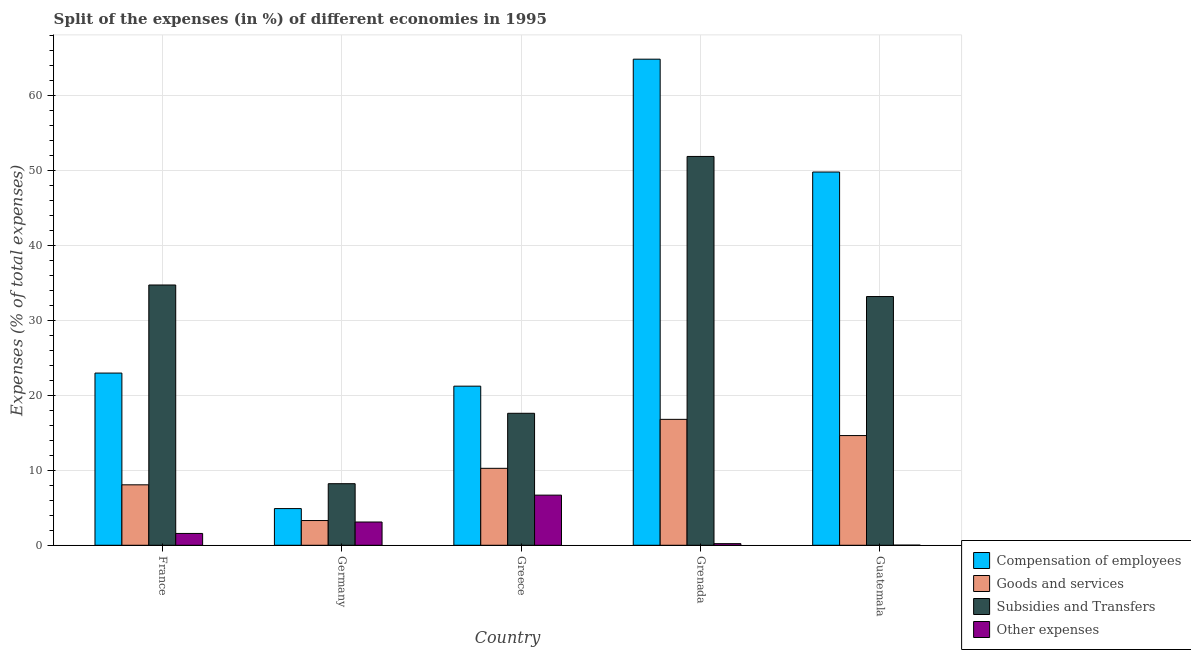How many different coloured bars are there?
Give a very brief answer. 4. How many groups of bars are there?
Your answer should be very brief. 5. Are the number of bars per tick equal to the number of legend labels?
Give a very brief answer. Yes. How many bars are there on the 2nd tick from the right?
Provide a short and direct response. 4. What is the label of the 3rd group of bars from the left?
Offer a very short reply. Greece. What is the percentage of amount spent on other expenses in Grenada?
Offer a terse response. 0.22. Across all countries, what is the maximum percentage of amount spent on other expenses?
Your answer should be compact. 6.69. Across all countries, what is the minimum percentage of amount spent on subsidies?
Your response must be concise. 8.22. In which country was the percentage of amount spent on other expenses maximum?
Make the answer very short. Greece. In which country was the percentage of amount spent on goods and services minimum?
Make the answer very short. Germany. What is the total percentage of amount spent on other expenses in the graph?
Offer a very short reply. 11.61. What is the difference between the percentage of amount spent on other expenses in France and that in Germany?
Ensure brevity in your answer.  -1.52. What is the difference between the percentage of amount spent on goods and services in Grenada and the percentage of amount spent on other expenses in Greece?
Offer a very short reply. 10.11. What is the average percentage of amount spent on subsidies per country?
Offer a terse response. 29.12. What is the difference between the percentage of amount spent on subsidies and percentage of amount spent on goods and services in Guatemala?
Keep it short and to the point. 18.55. In how many countries, is the percentage of amount spent on other expenses greater than 58 %?
Your response must be concise. 0. What is the ratio of the percentage of amount spent on subsidies in Greece to that in Grenada?
Make the answer very short. 0.34. Is the percentage of amount spent on other expenses in France less than that in Greece?
Offer a very short reply. Yes. Is the difference between the percentage of amount spent on goods and services in France and Germany greater than the difference between the percentage of amount spent on other expenses in France and Germany?
Ensure brevity in your answer.  Yes. What is the difference between the highest and the second highest percentage of amount spent on subsidies?
Your answer should be compact. 17.15. What is the difference between the highest and the lowest percentage of amount spent on other expenses?
Your response must be concise. 6.67. Is it the case that in every country, the sum of the percentage of amount spent on compensation of employees and percentage of amount spent on other expenses is greater than the sum of percentage of amount spent on goods and services and percentage of amount spent on subsidies?
Provide a succinct answer. Yes. What does the 2nd bar from the left in Greece represents?
Offer a terse response. Goods and services. What does the 2nd bar from the right in Germany represents?
Give a very brief answer. Subsidies and Transfers. How many bars are there?
Your answer should be very brief. 20. How many countries are there in the graph?
Your answer should be compact. 5. What is the difference between two consecutive major ticks on the Y-axis?
Offer a very short reply. 10. Are the values on the major ticks of Y-axis written in scientific E-notation?
Make the answer very short. No. Does the graph contain grids?
Provide a succinct answer. Yes. Where does the legend appear in the graph?
Provide a succinct answer. Bottom right. How many legend labels are there?
Your answer should be very brief. 4. What is the title of the graph?
Offer a very short reply. Split of the expenses (in %) of different economies in 1995. What is the label or title of the Y-axis?
Your answer should be very brief. Expenses (% of total expenses). What is the Expenses (% of total expenses) in Compensation of employees in France?
Make the answer very short. 22.97. What is the Expenses (% of total expenses) of Goods and services in France?
Provide a succinct answer. 8.07. What is the Expenses (% of total expenses) in Subsidies and Transfers in France?
Your answer should be compact. 34.73. What is the Expenses (% of total expenses) of Other expenses in France?
Your answer should be very brief. 1.58. What is the Expenses (% of total expenses) of Compensation of employees in Germany?
Make the answer very short. 4.9. What is the Expenses (% of total expenses) of Goods and services in Germany?
Provide a succinct answer. 3.3. What is the Expenses (% of total expenses) in Subsidies and Transfers in Germany?
Your answer should be compact. 8.22. What is the Expenses (% of total expenses) of Other expenses in Germany?
Provide a succinct answer. 3.1. What is the Expenses (% of total expenses) of Compensation of employees in Greece?
Ensure brevity in your answer.  21.23. What is the Expenses (% of total expenses) in Goods and services in Greece?
Your response must be concise. 10.27. What is the Expenses (% of total expenses) of Subsidies and Transfers in Greece?
Provide a succinct answer. 17.61. What is the Expenses (% of total expenses) of Other expenses in Greece?
Keep it short and to the point. 6.69. What is the Expenses (% of total expenses) in Compensation of employees in Grenada?
Give a very brief answer. 64.85. What is the Expenses (% of total expenses) in Goods and services in Grenada?
Keep it short and to the point. 16.8. What is the Expenses (% of total expenses) in Subsidies and Transfers in Grenada?
Offer a very short reply. 51.88. What is the Expenses (% of total expenses) of Other expenses in Grenada?
Offer a very short reply. 0.22. What is the Expenses (% of total expenses) in Compensation of employees in Guatemala?
Your answer should be very brief. 49.8. What is the Expenses (% of total expenses) in Goods and services in Guatemala?
Give a very brief answer. 14.64. What is the Expenses (% of total expenses) of Subsidies and Transfers in Guatemala?
Offer a terse response. 33.19. What is the Expenses (% of total expenses) of Other expenses in Guatemala?
Make the answer very short. 0.02. Across all countries, what is the maximum Expenses (% of total expenses) of Compensation of employees?
Make the answer very short. 64.85. Across all countries, what is the maximum Expenses (% of total expenses) in Goods and services?
Your answer should be compact. 16.8. Across all countries, what is the maximum Expenses (% of total expenses) in Subsidies and Transfers?
Make the answer very short. 51.88. Across all countries, what is the maximum Expenses (% of total expenses) in Other expenses?
Keep it short and to the point. 6.69. Across all countries, what is the minimum Expenses (% of total expenses) of Compensation of employees?
Keep it short and to the point. 4.9. Across all countries, what is the minimum Expenses (% of total expenses) of Goods and services?
Provide a short and direct response. 3.3. Across all countries, what is the minimum Expenses (% of total expenses) in Subsidies and Transfers?
Offer a terse response. 8.22. Across all countries, what is the minimum Expenses (% of total expenses) of Other expenses?
Provide a short and direct response. 0.02. What is the total Expenses (% of total expenses) of Compensation of employees in the graph?
Make the answer very short. 163.75. What is the total Expenses (% of total expenses) in Goods and services in the graph?
Make the answer very short. 53.07. What is the total Expenses (% of total expenses) of Subsidies and Transfers in the graph?
Your answer should be compact. 145.61. What is the total Expenses (% of total expenses) of Other expenses in the graph?
Offer a very short reply. 11.61. What is the difference between the Expenses (% of total expenses) of Compensation of employees in France and that in Germany?
Your answer should be very brief. 18.08. What is the difference between the Expenses (% of total expenses) in Goods and services in France and that in Germany?
Your response must be concise. 4.77. What is the difference between the Expenses (% of total expenses) in Subsidies and Transfers in France and that in Germany?
Provide a succinct answer. 26.51. What is the difference between the Expenses (% of total expenses) in Other expenses in France and that in Germany?
Ensure brevity in your answer.  -1.52. What is the difference between the Expenses (% of total expenses) in Compensation of employees in France and that in Greece?
Your answer should be compact. 1.75. What is the difference between the Expenses (% of total expenses) of Goods and services in France and that in Greece?
Your answer should be compact. -2.2. What is the difference between the Expenses (% of total expenses) in Subsidies and Transfers in France and that in Greece?
Offer a very short reply. 17.12. What is the difference between the Expenses (% of total expenses) of Other expenses in France and that in Greece?
Offer a terse response. -5.11. What is the difference between the Expenses (% of total expenses) in Compensation of employees in France and that in Grenada?
Give a very brief answer. -41.88. What is the difference between the Expenses (% of total expenses) of Goods and services in France and that in Grenada?
Provide a succinct answer. -8.73. What is the difference between the Expenses (% of total expenses) in Subsidies and Transfers in France and that in Grenada?
Your answer should be compact. -17.15. What is the difference between the Expenses (% of total expenses) in Other expenses in France and that in Grenada?
Provide a short and direct response. 1.36. What is the difference between the Expenses (% of total expenses) of Compensation of employees in France and that in Guatemala?
Offer a very short reply. -26.82. What is the difference between the Expenses (% of total expenses) in Goods and services in France and that in Guatemala?
Your response must be concise. -6.57. What is the difference between the Expenses (% of total expenses) of Subsidies and Transfers in France and that in Guatemala?
Give a very brief answer. 1.54. What is the difference between the Expenses (% of total expenses) of Other expenses in France and that in Guatemala?
Provide a succinct answer. 1.56. What is the difference between the Expenses (% of total expenses) of Compensation of employees in Germany and that in Greece?
Offer a terse response. -16.33. What is the difference between the Expenses (% of total expenses) of Goods and services in Germany and that in Greece?
Your response must be concise. -6.97. What is the difference between the Expenses (% of total expenses) in Subsidies and Transfers in Germany and that in Greece?
Your answer should be very brief. -9.39. What is the difference between the Expenses (% of total expenses) in Other expenses in Germany and that in Greece?
Keep it short and to the point. -3.59. What is the difference between the Expenses (% of total expenses) in Compensation of employees in Germany and that in Grenada?
Make the answer very short. -59.96. What is the difference between the Expenses (% of total expenses) in Goods and services in Germany and that in Grenada?
Offer a terse response. -13.5. What is the difference between the Expenses (% of total expenses) of Subsidies and Transfers in Germany and that in Grenada?
Make the answer very short. -43.66. What is the difference between the Expenses (% of total expenses) in Other expenses in Germany and that in Grenada?
Your response must be concise. 2.89. What is the difference between the Expenses (% of total expenses) in Compensation of employees in Germany and that in Guatemala?
Offer a very short reply. -44.9. What is the difference between the Expenses (% of total expenses) of Goods and services in Germany and that in Guatemala?
Ensure brevity in your answer.  -11.34. What is the difference between the Expenses (% of total expenses) in Subsidies and Transfers in Germany and that in Guatemala?
Keep it short and to the point. -24.97. What is the difference between the Expenses (% of total expenses) in Other expenses in Germany and that in Guatemala?
Your response must be concise. 3.09. What is the difference between the Expenses (% of total expenses) of Compensation of employees in Greece and that in Grenada?
Give a very brief answer. -43.63. What is the difference between the Expenses (% of total expenses) in Goods and services in Greece and that in Grenada?
Offer a very short reply. -6.53. What is the difference between the Expenses (% of total expenses) of Subsidies and Transfers in Greece and that in Grenada?
Your answer should be very brief. -34.27. What is the difference between the Expenses (% of total expenses) in Other expenses in Greece and that in Grenada?
Provide a succinct answer. 6.47. What is the difference between the Expenses (% of total expenses) of Compensation of employees in Greece and that in Guatemala?
Your response must be concise. -28.57. What is the difference between the Expenses (% of total expenses) in Goods and services in Greece and that in Guatemala?
Your answer should be compact. -4.37. What is the difference between the Expenses (% of total expenses) in Subsidies and Transfers in Greece and that in Guatemala?
Give a very brief answer. -15.58. What is the difference between the Expenses (% of total expenses) of Other expenses in Greece and that in Guatemala?
Your answer should be very brief. 6.67. What is the difference between the Expenses (% of total expenses) in Compensation of employees in Grenada and that in Guatemala?
Make the answer very short. 15.06. What is the difference between the Expenses (% of total expenses) of Goods and services in Grenada and that in Guatemala?
Offer a very short reply. 2.16. What is the difference between the Expenses (% of total expenses) in Subsidies and Transfers in Grenada and that in Guatemala?
Ensure brevity in your answer.  18.69. What is the difference between the Expenses (% of total expenses) in Other expenses in Grenada and that in Guatemala?
Provide a succinct answer. 0.2. What is the difference between the Expenses (% of total expenses) of Compensation of employees in France and the Expenses (% of total expenses) of Goods and services in Germany?
Your answer should be very brief. 19.67. What is the difference between the Expenses (% of total expenses) in Compensation of employees in France and the Expenses (% of total expenses) in Subsidies and Transfers in Germany?
Keep it short and to the point. 14.76. What is the difference between the Expenses (% of total expenses) in Compensation of employees in France and the Expenses (% of total expenses) in Other expenses in Germany?
Ensure brevity in your answer.  19.87. What is the difference between the Expenses (% of total expenses) in Goods and services in France and the Expenses (% of total expenses) in Subsidies and Transfers in Germany?
Your response must be concise. -0.15. What is the difference between the Expenses (% of total expenses) in Goods and services in France and the Expenses (% of total expenses) in Other expenses in Germany?
Make the answer very short. 4.96. What is the difference between the Expenses (% of total expenses) in Subsidies and Transfers in France and the Expenses (% of total expenses) in Other expenses in Germany?
Give a very brief answer. 31.62. What is the difference between the Expenses (% of total expenses) in Compensation of employees in France and the Expenses (% of total expenses) in Goods and services in Greece?
Make the answer very short. 12.71. What is the difference between the Expenses (% of total expenses) in Compensation of employees in France and the Expenses (% of total expenses) in Subsidies and Transfers in Greece?
Your response must be concise. 5.37. What is the difference between the Expenses (% of total expenses) of Compensation of employees in France and the Expenses (% of total expenses) of Other expenses in Greece?
Ensure brevity in your answer.  16.29. What is the difference between the Expenses (% of total expenses) in Goods and services in France and the Expenses (% of total expenses) in Subsidies and Transfers in Greece?
Your response must be concise. -9.54. What is the difference between the Expenses (% of total expenses) in Goods and services in France and the Expenses (% of total expenses) in Other expenses in Greece?
Offer a very short reply. 1.38. What is the difference between the Expenses (% of total expenses) in Subsidies and Transfers in France and the Expenses (% of total expenses) in Other expenses in Greece?
Offer a terse response. 28.04. What is the difference between the Expenses (% of total expenses) in Compensation of employees in France and the Expenses (% of total expenses) in Goods and services in Grenada?
Keep it short and to the point. 6.17. What is the difference between the Expenses (% of total expenses) in Compensation of employees in France and the Expenses (% of total expenses) in Subsidies and Transfers in Grenada?
Keep it short and to the point. -28.9. What is the difference between the Expenses (% of total expenses) in Compensation of employees in France and the Expenses (% of total expenses) in Other expenses in Grenada?
Provide a short and direct response. 22.76. What is the difference between the Expenses (% of total expenses) of Goods and services in France and the Expenses (% of total expenses) of Subsidies and Transfers in Grenada?
Keep it short and to the point. -43.81. What is the difference between the Expenses (% of total expenses) in Goods and services in France and the Expenses (% of total expenses) in Other expenses in Grenada?
Offer a very short reply. 7.85. What is the difference between the Expenses (% of total expenses) in Subsidies and Transfers in France and the Expenses (% of total expenses) in Other expenses in Grenada?
Provide a short and direct response. 34.51. What is the difference between the Expenses (% of total expenses) in Compensation of employees in France and the Expenses (% of total expenses) in Goods and services in Guatemala?
Your answer should be compact. 8.34. What is the difference between the Expenses (% of total expenses) of Compensation of employees in France and the Expenses (% of total expenses) of Subsidies and Transfers in Guatemala?
Offer a very short reply. -10.21. What is the difference between the Expenses (% of total expenses) in Compensation of employees in France and the Expenses (% of total expenses) in Other expenses in Guatemala?
Give a very brief answer. 22.96. What is the difference between the Expenses (% of total expenses) of Goods and services in France and the Expenses (% of total expenses) of Subsidies and Transfers in Guatemala?
Your answer should be compact. -25.12. What is the difference between the Expenses (% of total expenses) in Goods and services in France and the Expenses (% of total expenses) in Other expenses in Guatemala?
Your answer should be very brief. 8.05. What is the difference between the Expenses (% of total expenses) in Subsidies and Transfers in France and the Expenses (% of total expenses) in Other expenses in Guatemala?
Keep it short and to the point. 34.71. What is the difference between the Expenses (% of total expenses) in Compensation of employees in Germany and the Expenses (% of total expenses) in Goods and services in Greece?
Provide a succinct answer. -5.37. What is the difference between the Expenses (% of total expenses) of Compensation of employees in Germany and the Expenses (% of total expenses) of Subsidies and Transfers in Greece?
Offer a terse response. -12.71. What is the difference between the Expenses (% of total expenses) of Compensation of employees in Germany and the Expenses (% of total expenses) of Other expenses in Greece?
Your answer should be very brief. -1.79. What is the difference between the Expenses (% of total expenses) in Goods and services in Germany and the Expenses (% of total expenses) in Subsidies and Transfers in Greece?
Offer a very short reply. -14.31. What is the difference between the Expenses (% of total expenses) of Goods and services in Germany and the Expenses (% of total expenses) of Other expenses in Greece?
Ensure brevity in your answer.  -3.39. What is the difference between the Expenses (% of total expenses) in Subsidies and Transfers in Germany and the Expenses (% of total expenses) in Other expenses in Greece?
Your answer should be compact. 1.53. What is the difference between the Expenses (% of total expenses) in Compensation of employees in Germany and the Expenses (% of total expenses) in Goods and services in Grenada?
Your response must be concise. -11.9. What is the difference between the Expenses (% of total expenses) of Compensation of employees in Germany and the Expenses (% of total expenses) of Subsidies and Transfers in Grenada?
Make the answer very short. -46.98. What is the difference between the Expenses (% of total expenses) in Compensation of employees in Germany and the Expenses (% of total expenses) in Other expenses in Grenada?
Provide a succinct answer. 4.68. What is the difference between the Expenses (% of total expenses) in Goods and services in Germany and the Expenses (% of total expenses) in Subsidies and Transfers in Grenada?
Your answer should be compact. -48.58. What is the difference between the Expenses (% of total expenses) of Goods and services in Germany and the Expenses (% of total expenses) of Other expenses in Grenada?
Ensure brevity in your answer.  3.08. What is the difference between the Expenses (% of total expenses) of Subsidies and Transfers in Germany and the Expenses (% of total expenses) of Other expenses in Grenada?
Your answer should be compact. 8. What is the difference between the Expenses (% of total expenses) of Compensation of employees in Germany and the Expenses (% of total expenses) of Goods and services in Guatemala?
Keep it short and to the point. -9.74. What is the difference between the Expenses (% of total expenses) of Compensation of employees in Germany and the Expenses (% of total expenses) of Subsidies and Transfers in Guatemala?
Offer a terse response. -28.29. What is the difference between the Expenses (% of total expenses) in Compensation of employees in Germany and the Expenses (% of total expenses) in Other expenses in Guatemala?
Provide a succinct answer. 4.88. What is the difference between the Expenses (% of total expenses) in Goods and services in Germany and the Expenses (% of total expenses) in Subsidies and Transfers in Guatemala?
Provide a succinct answer. -29.89. What is the difference between the Expenses (% of total expenses) in Goods and services in Germany and the Expenses (% of total expenses) in Other expenses in Guatemala?
Keep it short and to the point. 3.28. What is the difference between the Expenses (% of total expenses) in Subsidies and Transfers in Germany and the Expenses (% of total expenses) in Other expenses in Guatemala?
Ensure brevity in your answer.  8.2. What is the difference between the Expenses (% of total expenses) in Compensation of employees in Greece and the Expenses (% of total expenses) in Goods and services in Grenada?
Provide a succinct answer. 4.43. What is the difference between the Expenses (% of total expenses) of Compensation of employees in Greece and the Expenses (% of total expenses) of Subsidies and Transfers in Grenada?
Provide a succinct answer. -30.65. What is the difference between the Expenses (% of total expenses) of Compensation of employees in Greece and the Expenses (% of total expenses) of Other expenses in Grenada?
Ensure brevity in your answer.  21.01. What is the difference between the Expenses (% of total expenses) of Goods and services in Greece and the Expenses (% of total expenses) of Subsidies and Transfers in Grenada?
Ensure brevity in your answer.  -41.61. What is the difference between the Expenses (% of total expenses) of Goods and services in Greece and the Expenses (% of total expenses) of Other expenses in Grenada?
Give a very brief answer. 10.05. What is the difference between the Expenses (% of total expenses) in Subsidies and Transfers in Greece and the Expenses (% of total expenses) in Other expenses in Grenada?
Make the answer very short. 17.39. What is the difference between the Expenses (% of total expenses) of Compensation of employees in Greece and the Expenses (% of total expenses) of Goods and services in Guatemala?
Your answer should be compact. 6.59. What is the difference between the Expenses (% of total expenses) of Compensation of employees in Greece and the Expenses (% of total expenses) of Subsidies and Transfers in Guatemala?
Offer a terse response. -11.96. What is the difference between the Expenses (% of total expenses) of Compensation of employees in Greece and the Expenses (% of total expenses) of Other expenses in Guatemala?
Your response must be concise. 21.21. What is the difference between the Expenses (% of total expenses) of Goods and services in Greece and the Expenses (% of total expenses) of Subsidies and Transfers in Guatemala?
Your response must be concise. -22.92. What is the difference between the Expenses (% of total expenses) of Goods and services in Greece and the Expenses (% of total expenses) of Other expenses in Guatemala?
Offer a very short reply. 10.25. What is the difference between the Expenses (% of total expenses) of Subsidies and Transfers in Greece and the Expenses (% of total expenses) of Other expenses in Guatemala?
Offer a terse response. 17.59. What is the difference between the Expenses (% of total expenses) in Compensation of employees in Grenada and the Expenses (% of total expenses) in Goods and services in Guatemala?
Provide a short and direct response. 50.22. What is the difference between the Expenses (% of total expenses) of Compensation of employees in Grenada and the Expenses (% of total expenses) of Subsidies and Transfers in Guatemala?
Give a very brief answer. 31.67. What is the difference between the Expenses (% of total expenses) of Compensation of employees in Grenada and the Expenses (% of total expenses) of Other expenses in Guatemala?
Make the answer very short. 64.84. What is the difference between the Expenses (% of total expenses) of Goods and services in Grenada and the Expenses (% of total expenses) of Subsidies and Transfers in Guatemala?
Provide a succinct answer. -16.39. What is the difference between the Expenses (% of total expenses) of Goods and services in Grenada and the Expenses (% of total expenses) of Other expenses in Guatemala?
Provide a short and direct response. 16.78. What is the difference between the Expenses (% of total expenses) in Subsidies and Transfers in Grenada and the Expenses (% of total expenses) in Other expenses in Guatemala?
Give a very brief answer. 51.86. What is the average Expenses (% of total expenses) in Compensation of employees per country?
Offer a very short reply. 32.75. What is the average Expenses (% of total expenses) in Goods and services per country?
Offer a very short reply. 10.61. What is the average Expenses (% of total expenses) of Subsidies and Transfers per country?
Give a very brief answer. 29.12. What is the average Expenses (% of total expenses) of Other expenses per country?
Provide a short and direct response. 2.32. What is the difference between the Expenses (% of total expenses) in Compensation of employees and Expenses (% of total expenses) in Goods and services in France?
Ensure brevity in your answer.  14.91. What is the difference between the Expenses (% of total expenses) in Compensation of employees and Expenses (% of total expenses) in Subsidies and Transfers in France?
Offer a very short reply. -11.75. What is the difference between the Expenses (% of total expenses) in Compensation of employees and Expenses (% of total expenses) in Other expenses in France?
Keep it short and to the point. 21.4. What is the difference between the Expenses (% of total expenses) in Goods and services and Expenses (% of total expenses) in Subsidies and Transfers in France?
Provide a short and direct response. -26.66. What is the difference between the Expenses (% of total expenses) of Goods and services and Expenses (% of total expenses) of Other expenses in France?
Your answer should be very brief. 6.49. What is the difference between the Expenses (% of total expenses) of Subsidies and Transfers and Expenses (% of total expenses) of Other expenses in France?
Your answer should be very brief. 33.15. What is the difference between the Expenses (% of total expenses) in Compensation of employees and Expenses (% of total expenses) in Goods and services in Germany?
Your answer should be very brief. 1.59. What is the difference between the Expenses (% of total expenses) of Compensation of employees and Expenses (% of total expenses) of Subsidies and Transfers in Germany?
Provide a short and direct response. -3.32. What is the difference between the Expenses (% of total expenses) of Compensation of employees and Expenses (% of total expenses) of Other expenses in Germany?
Your response must be concise. 1.79. What is the difference between the Expenses (% of total expenses) of Goods and services and Expenses (% of total expenses) of Subsidies and Transfers in Germany?
Ensure brevity in your answer.  -4.91. What is the difference between the Expenses (% of total expenses) of Goods and services and Expenses (% of total expenses) of Other expenses in Germany?
Ensure brevity in your answer.  0.2. What is the difference between the Expenses (% of total expenses) in Subsidies and Transfers and Expenses (% of total expenses) in Other expenses in Germany?
Your answer should be very brief. 5.11. What is the difference between the Expenses (% of total expenses) of Compensation of employees and Expenses (% of total expenses) of Goods and services in Greece?
Offer a very short reply. 10.96. What is the difference between the Expenses (% of total expenses) in Compensation of employees and Expenses (% of total expenses) in Subsidies and Transfers in Greece?
Your answer should be compact. 3.62. What is the difference between the Expenses (% of total expenses) in Compensation of employees and Expenses (% of total expenses) in Other expenses in Greece?
Your answer should be very brief. 14.54. What is the difference between the Expenses (% of total expenses) in Goods and services and Expenses (% of total expenses) in Subsidies and Transfers in Greece?
Provide a succinct answer. -7.34. What is the difference between the Expenses (% of total expenses) in Goods and services and Expenses (% of total expenses) in Other expenses in Greece?
Your answer should be very brief. 3.58. What is the difference between the Expenses (% of total expenses) in Subsidies and Transfers and Expenses (% of total expenses) in Other expenses in Greece?
Make the answer very short. 10.92. What is the difference between the Expenses (% of total expenses) in Compensation of employees and Expenses (% of total expenses) in Goods and services in Grenada?
Your response must be concise. 48.05. What is the difference between the Expenses (% of total expenses) in Compensation of employees and Expenses (% of total expenses) in Subsidies and Transfers in Grenada?
Your response must be concise. 12.98. What is the difference between the Expenses (% of total expenses) in Compensation of employees and Expenses (% of total expenses) in Other expenses in Grenada?
Provide a short and direct response. 64.64. What is the difference between the Expenses (% of total expenses) in Goods and services and Expenses (% of total expenses) in Subsidies and Transfers in Grenada?
Provide a short and direct response. -35.08. What is the difference between the Expenses (% of total expenses) in Goods and services and Expenses (% of total expenses) in Other expenses in Grenada?
Provide a short and direct response. 16.58. What is the difference between the Expenses (% of total expenses) of Subsidies and Transfers and Expenses (% of total expenses) of Other expenses in Grenada?
Provide a short and direct response. 51.66. What is the difference between the Expenses (% of total expenses) in Compensation of employees and Expenses (% of total expenses) in Goods and services in Guatemala?
Provide a short and direct response. 35.16. What is the difference between the Expenses (% of total expenses) in Compensation of employees and Expenses (% of total expenses) in Subsidies and Transfers in Guatemala?
Offer a terse response. 16.61. What is the difference between the Expenses (% of total expenses) in Compensation of employees and Expenses (% of total expenses) in Other expenses in Guatemala?
Offer a terse response. 49.78. What is the difference between the Expenses (% of total expenses) in Goods and services and Expenses (% of total expenses) in Subsidies and Transfers in Guatemala?
Your response must be concise. -18.55. What is the difference between the Expenses (% of total expenses) in Goods and services and Expenses (% of total expenses) in Other expenses in Guatemala?
Your answer should be very brief. 14.62. What is the difference between the Expenses (% of total expenses) in Subsidies and Transfers and Expenses (% of total expenses) in Other expenses in Guatemala?
Ensure brevity in your answer.  33.17. What is the ratio of the Expenses (% of total expenses) in Compensation of employees in France to that in Germany?
Provide a succinct answer. 4.69. What is the ratio of the Expenses (% of total expenses) of Goods and services in France to that in Germany?
Provide a succinct answer. 2.44. What is the ratio of the Expenses (% of total expenses) of Subsidies and Transfers in France to that in Germany?
Your answer should be very brief. 4.23. What is the ratio of the Expenses (% of total expenses) of Other expenses in France to that in Germany?
Your answer should be very brief. 0.51. What is the ratio of the Expenses (% of total expenses) in Compensation of employees in France to that in Greece?
Provide a short and direct response. 1.08. What is the ratio of the Expenses (% of total expenses) in Goods and services in France to that in Greece?
Your answer should be compact. 0.79. What is the ratio of the Expenses (% of total expenses) in Subsidies and Transfers in France to that in Greece?
Offer a terse response. 1.97. What is the ratio of the Expenses (% of total expenses) in Other expenses in France to that in Greece?
Ensure brevity in your answer.  0.24. What is the ratio of the Expenses (% of total expenses) of Compensation of employees in France to that in Grenada?
Ensure brevity in your answer.  0.35. What is the ratio of the Expenses (% of total expenses) of Goods and services in France to that in Grenada?
Your answer should be very brief. 0.48. What is the ratio of the Expenses (% of total expenses) of Subsidies and Transfers in France to that in Grenada?
Your answer should be very brief. 0.67. What is the ratio of the Expenses (% of total expenses) of Other expenses in France to that in Grenada?
Offer a terse response. 7.26. What is the ratio of the Expenses (% of total expenses) of Compensation of employees in France to that in Guatemala?
Your answer should be compact. 0.46. What is the ratio of the Expenses (% of total expenses) in Goods and services in France to that in Guatemala?
Your answer should be compact. 0.55. What is the ratio of the Expenses (% of total expenses) of Subsidies and Transfers in France to that in Guatemala?
Provide a succinct answer. 1.05. What is the ratio of the Expenses (% of total expenses) of Other expenses in France to that in Guatemala?
Offer a terse response. 85.76. What is the ratio of the Expenses (% of total expenses) in Compensation of employees in Germany to that in Greece?
Provide a short and direct response. 0.23. What is the ratio of the Expenses (% of total expenses) of Goods and services in Germany to that in Greece?
Keep it short and to the point. 0.32. What is the ratio of the Expenses (% of total expenses) of Subsidies and Transfers in Germany to that in Greece?
Provide a short and direct response. 0.47. What is the ratio of the Expenses (% of total expenses) of Other expenses in Germany to that in Greece?
Give a very brief answer. 0.46. What is the ratio of the Expenses (% of total expenses) of Compensation of employees in Germany to that in Grenada?
Give a very brief answer. 0.08. What is the ratio of the Expenses (% of total expenses) in Goods and services in Germany to that in Grenada?
Your answer should be very brief. 0.2. What is the ratio of the Expenses (% of total expenses) in Subsidies and Transfers in Germany to that in Grenada?
Provide a succinct answer. 0.16. What is the ratio of the Expenses (% of total expenses) in Other expenses in Germany to that in Grenada?
Make the answer very short. 14.26. What is the ratio of the Expenses (% of total expenses) in Compensation of employees in Germany to that in Guatemala?
Provide a short and direct response. 0.1. What is the ratio of the Expenses (% of total expenses) of Goods and services in Germany to that in Guatemala?
Give a very brief answer. 0.23. What is the ratio of the Expenses (% of total expenses) of Subsidies and Transfers in Germany to that in Guatemala?
Your response must be concise. 0.25. What is the ratio of the Expenses (% of total expenses) of Other expenses in Germany to that in Guatemala?
Give a very brief answer. 168.57. What is the ratio of the Expenses (% of total expenses) of Compensation of employees in Greece to that in Grenada?
Offer a very short reply. 0.33. What is the ratio of the Expenses (% of total expenses) in Goods and services in Greece to that in Grenada?
Ensure brevity in your answer.  0.61. What is the ratio of the Expenses (% of total expenses) in Subsidies and Transfers in Greece to that in Grenada?
Provide a short and direct response. 0.34. What is the ratio of the Expenses (% of total expenses) in Other expenses in Greece to that in Grenada?
Make the answer very short. 30.74. What is the ratio of the Expenses (% of total expenses) in Compensation of employees in Greece to that in Guatemala?
Ensure brevity in your answer.  0.43. What is the ratio of the Expenses (% of total expenses) in Goods and services in Greece to that in Guatemala?
Provide a succinct answer. 0.7. What is the ratio of the Expenses (% of total expenses) in Subsidies and Transfers in Greece to that in Guatemala?
Your response must be concise. 0.53. What is the ratio of the Expenses (% of total expenses) in Other expenses in Greece to that in Guatemala?
Offer a terse response. 363.32. What is the ratio of the Expenses (% of total expenses) of Compensation of employees in Grenada to that in Guatemala?
Offer a terse response. 1.3. What is the ratio of the Expenses (% of total expenses) of Goods and services in Grenada to that in Guatemala?
Provide a succinct answer. 1.15. What is the ratio of the Expenses (% of total expenses) of Subsidies and Transfers in Grenada to that in Guatemala?
Make the answer very short. 1.56. What is the ratio of the Expenses (% of total expenses) in Other expenses in Grenada to that in Guatemala?
Keep it short and to the point. 11.82. What is the difference between the highest and the second highest Expenses (% of total expenses) in Compensation of employees?
Provide a succinct answer. 15.06. What is the difference between the highest and the second highest Expenses (% of total expenses) in Goods and services?
Offer a terse response. 2.16. What is the difference between the highest and the second highest Expenses (% of total expenses) of Subsidies and Transfers?
Your answer should be compact. 17.15. What is the difference between the highest and the second highest Expenses (% of total expenses) of Other expenses?
Offer a very short reply. 3.59. What is the difference between the highest and the lowest Expenses (% of total expenses) of Compensation of employees?
Your answer should be very brief. 59.96. What is the difference between the highest and the lowest Expenses (% of total expenses) in Goods and services?
Give a very brief answer. 13.5. What is the difference between the highest and the lowest Expenses (% of total expenses) of Subsidies and Transfers?
Ensure brevity in your answer.  43.66. What is the difference between the highest and the lowest Expenses (% of total expenses) in Other expenses?
Make the answer very short. 6.67. 